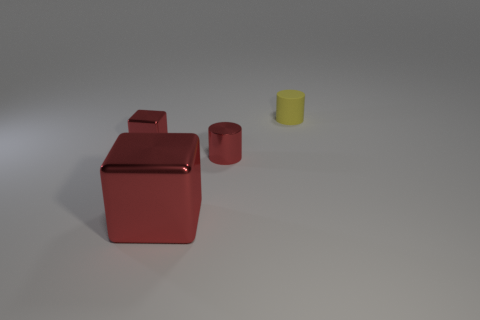Is the small cylinder in front of the tiny yellow rubber object made of the same material as the small object behind the tiny red shiny block?
Provide a succinct answer. No. How many other objects are there of the same size as the red cylinder?
Your response must be concise. 2. How many things are red cylinders or small cylinders that are left of the tiny yellow thing?
Your answer should be compact. 1. Are there an equal number of small cylinders on the right side of the tiny matte thing and shiny things?
Ensure brevity in your answer.  No. What is the shape of the big thing that is made of the same material as the small red block?
Provide a succinct answer. Cube. Is there another shiny block that has the same color as the large shiny block?
Offer a terse response. Yes. What number of rubber things are either small cubes or big gray things?
Keep it short and to the point. 0. What number of tiny yellow objects are to the right of the shiny thing right of the large block?
Keep it short and to the point. 1. Are there an equal number of tiny red cylinders and red things?
Provide a succinct answer. No. What number of small red cylinders have the same material as the big red thing?
Your answer should be very brief. 1. 